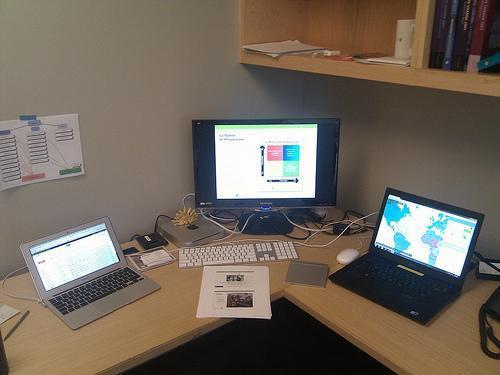How many computers are shown?
Give a very brief answer. 3. 